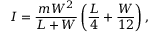<formula> <loc_0><loc_0><loc_500><loc_500>I = \frac { m W ^ { 2 } } { L + W } \left ( \frac { L } { 4 } + \frac { W } { 1 2 } \right ) ,</formula> 